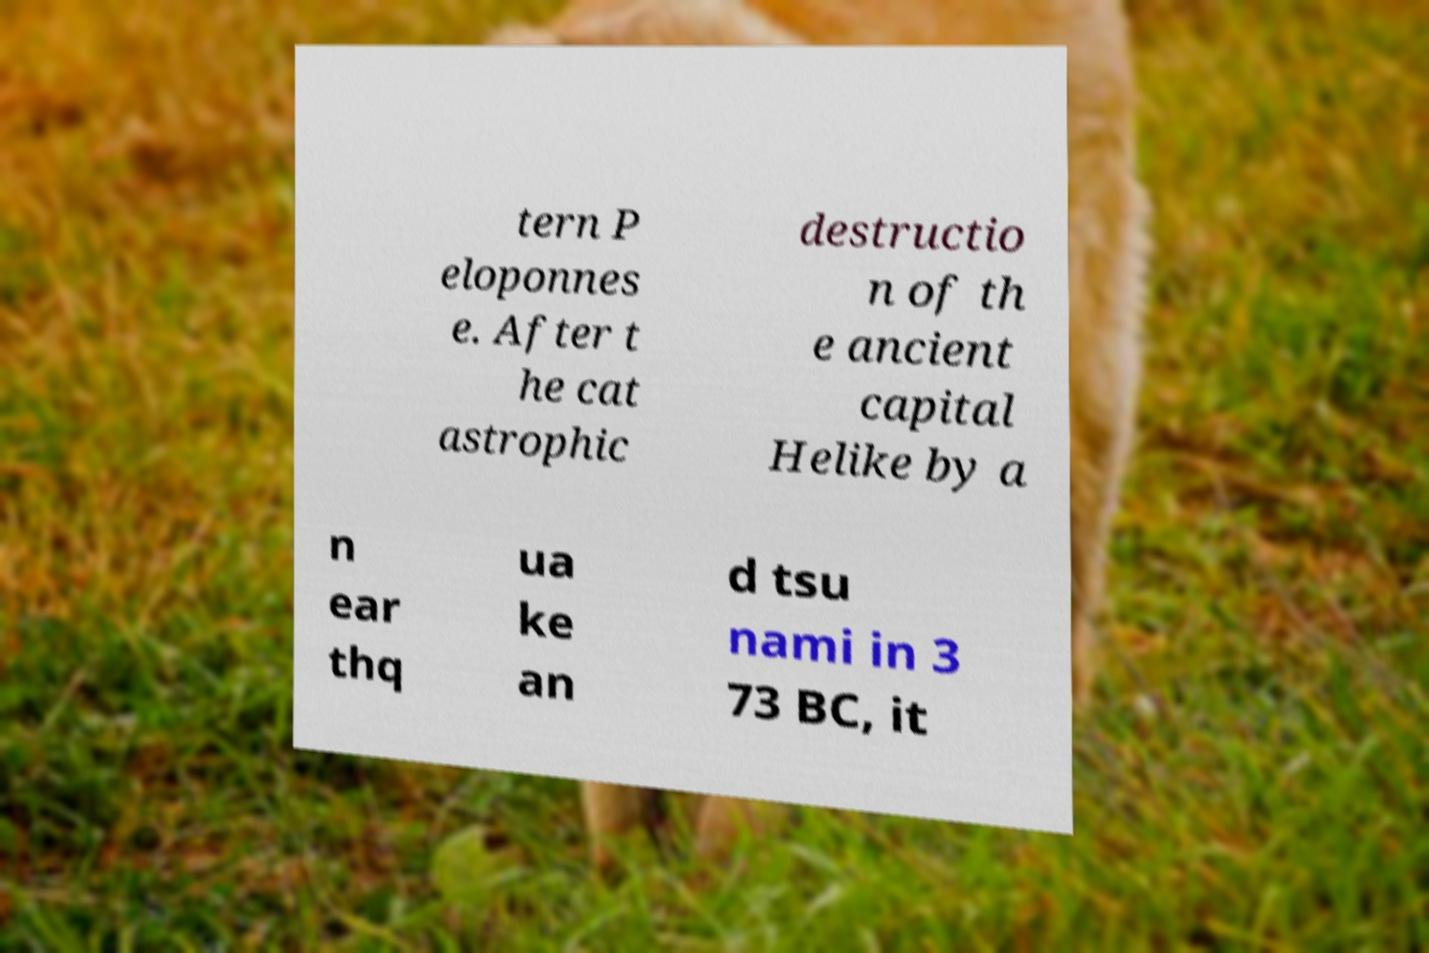For documentation purposes, I need the text within this image transcribed. Could you provide that? tern P eloponnes e. After t he cat astrophic destructio n of th e ancient capital Helike by a n ear thq ua ke an d tsu nami in 3 73 BC, it 